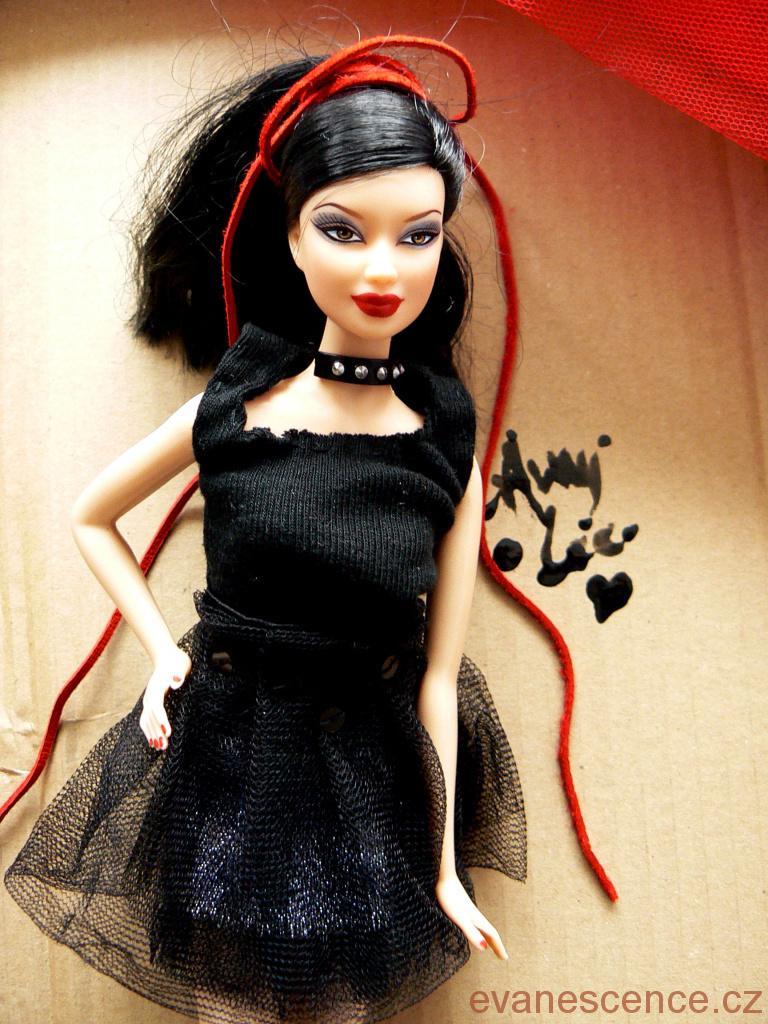Please provide a concise description of this image. In this image in the center there is one doll and in the background there is some box, at the bottom of the image there is some text. 